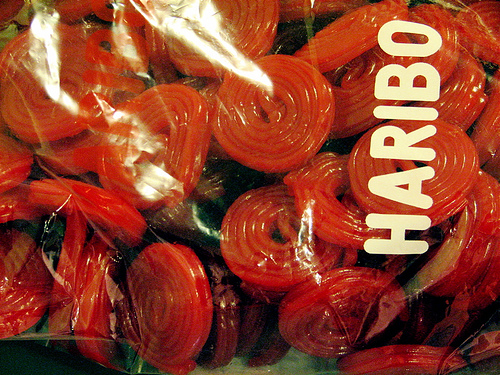<image>
Can you confirm if the letter is to the left of the candy? Yes. From this viewpoint, the letter is positioned to the left side relative to the candy. 